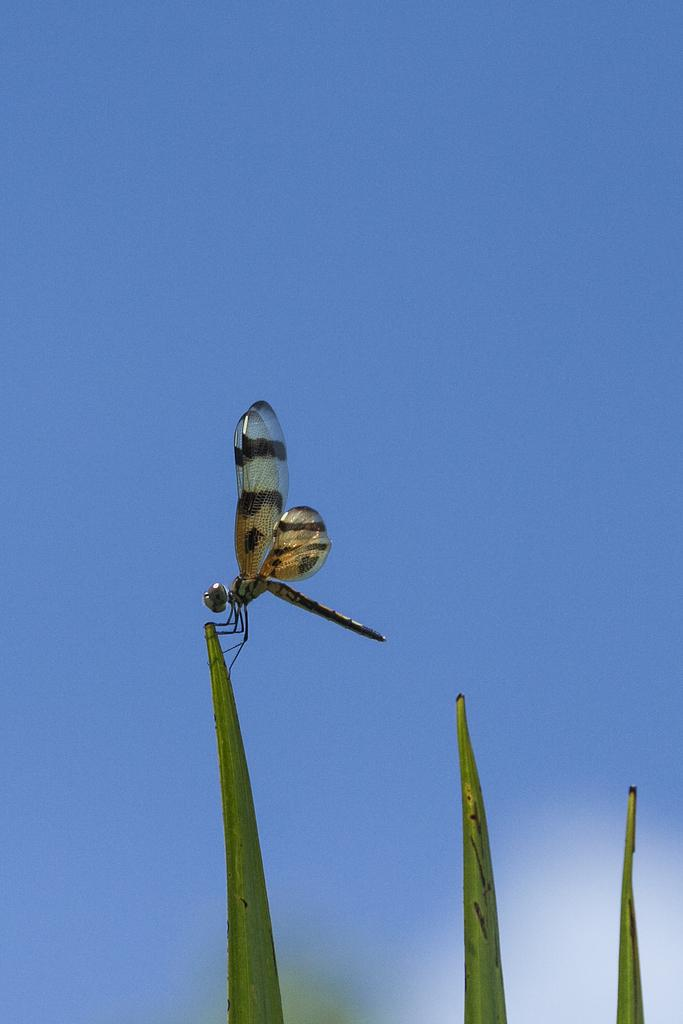What is the main subject of the image? There is a dragonfly in the center of the image. What can be seen in the background of the image? The sky is visible in the background of the image. What type of disease is affecting the dragonfly in the image? There is no indication of any disease affecting the dragonfly in the image. What type of tank is visible in the image? There is no tank present in the image; it features a dragonfly and the sky. 